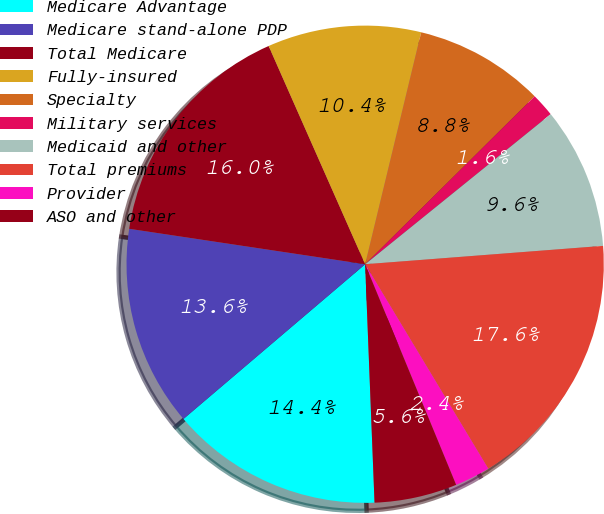Convert chart. <chart><loc_0><loc_0><loc_500><loc_500><pie_chart><fcel>Medicare Advantage<fcel>Medicare stand-alone PDP<fcel>Total Medicare<fcel>Fully-insured<fcel>Specialty<fcel>Military services<fcel>Medicaid and other<fcel>Total premiums<fcel>Provider<fcel>ASO and other<nl><fcel>14.4%<fcel>13.6%<fcel>16.0%<fcel>10.4%<fcel>8.8%<fcel>1.6%<fcel>9.6%<fcel>17.6%<fcel>2.4%<fcel>5.6%<nl></chart> 